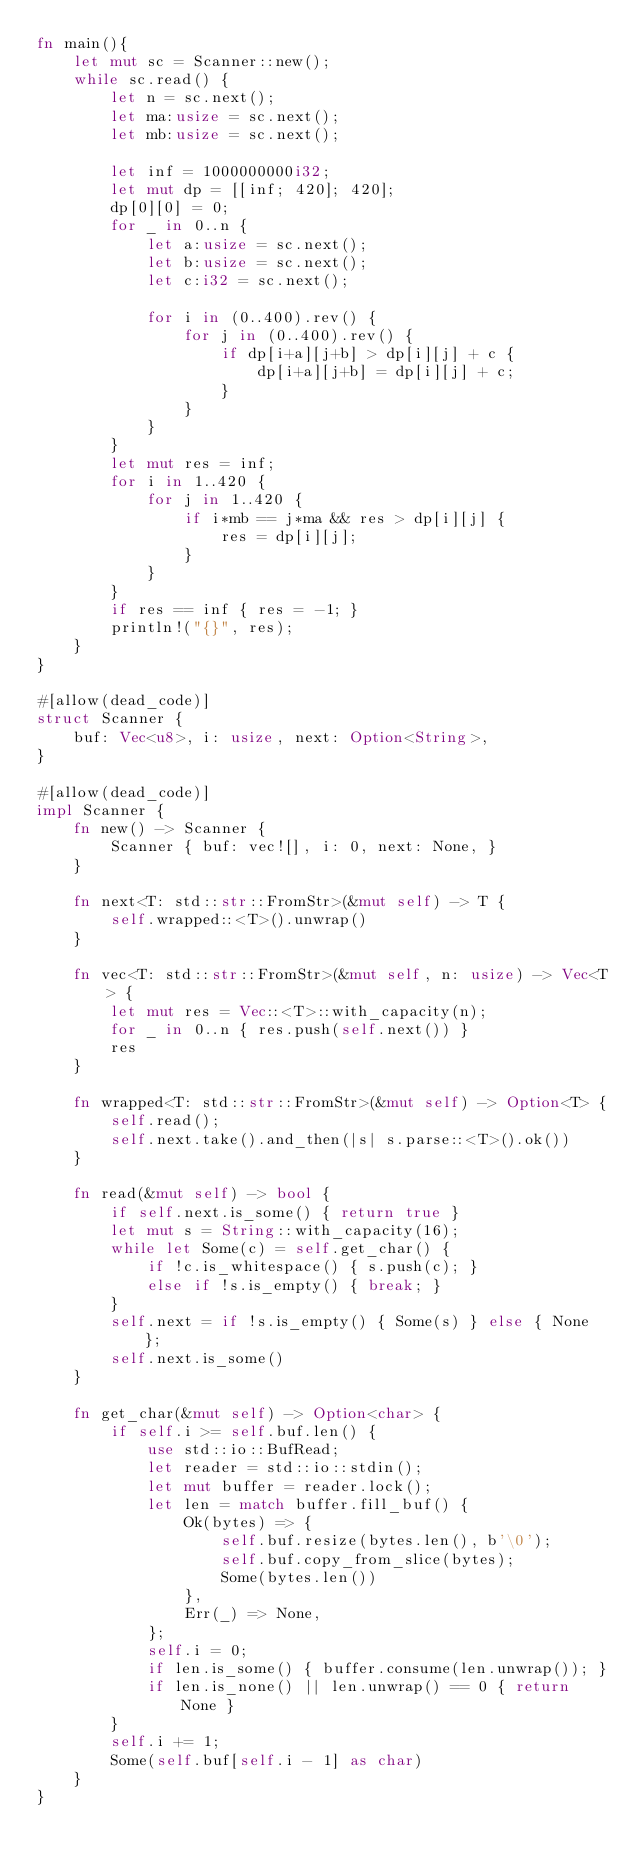<code> <loc_0><loc_0><loc_500><loc_500><_Rust_>fn main(){
    let mut sc = Scanner::new();
    while sc.read() {
        let n = sc.next();
        let ma:usize = sc.next();
        let mb:usize = sc.next();

        let inf = 1000000000i32;
        let mut dp = [[inf; 420]; 420];
        dp[0][0] = 0;
        for _ in 0..n {
            let a:usize = sc.next();
            let b:usize = sc.next();
            let c:i32 = sc.next();
            
            for i in (0..400).rev() {
                for j in (0..400).rev() {
                    if dp[i+a][j+b] > dp[i][j] + c {
                        dp[i+a][j+b] = dp[i][j] + c;
                    }
                }
            }
        }
        let mut res = inf;
        for i in 1..420 {
            for j in 1..420 {
                if i*mb == j*ma && res > dp[i][j] {
                    res = dp[i][j];
                }
            }
        }
        if res == inf { res = -1; }
        println!("{}", res);
    }
}

#[allow(dead_code)]
struct Scanner {
    buf: Vec<u8>, i: usize, next: Option<String>,
}

#[allow(dead_code)]
impl Scanner {
    fn new() -> Scanner {
        Scanner { buf: vec![], i: 0, next: None, }
    }

    fn next<T: std::str::FromStr>(&mut self) -> T {
        self.wrapped::<T>().unwrap()
    }

    fn vec<T: std::str::FromStr>(&mut self, n: usize) -> Vec<T> {
        let mut res = Vec::<T>::with_capacity(n);
        for _ in 0..n { res.push(self.next()) }
        res
    }

    fn wrapped<T: std::str::FromStr>(&mut self) -> Option<T> {
        self.read();
        self.next.take().and_then(|s| s.parse::<T>().ok())
    }

    fn read(&mut self) -> bool {
        if self.next.is_some() { return true }
        let mut s = String::with_capacity(16);
        while let Some(c) = self.get_char() {
            if !c.is_whitespace() { s.push(c); }
            else if !s.is_empty() { break; }
        }
        self.next = if !s.is_empty() { Some(s) } else { None };
        self.next.is_some()
    }

    fn get_char(&mut self) -> Option<char> {
        if self.i >= self.buf.len() {
            use std::io::BufRead;
            let reader = std::io::stdin();
            let mut buffer = reader.lock();
            let len = match buffer.fill_buf() {
                Ok(bytes) => {
                    self.buf.resize(bytes.len(), b'\0');
                    self.buf.copy_from_slice(bytes);
                    Some(bytes.len())
                },
                Err(_) => None,
            };
            self.i = 0;
            if len.is_some() { buffer.consume(len.unwrap()); }
            if len.is_none() || len.unwrap() == 0 { return None }
        }
        self.i += 1;
        Some(self.buf[self.i - 1] as char)
    }
}
</code> 